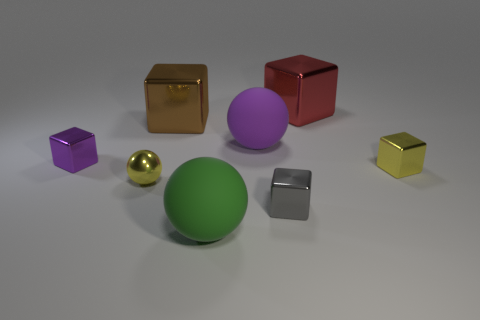Subtract all red cubes. How many cubes are left? 4 Subtract all red blocks. How many blocks are left? 4 Subtract all cyan cubes. Subtract all brown balls. How many cubes are left? 5 Subtract all spheres. How many objects are left? 5 Add 1 tiny red cylinders. How many objects exist? 9 Subtract 1 brown blocks. How many objects are left? 7 Subtract all large purple matte objects. Subtract all small gray things. How many objects are left? 6 Add 1 green balls. How many green balls are left? 2 Add 4 yellow metal cubes. How many yellow metal cubes exist? 5 